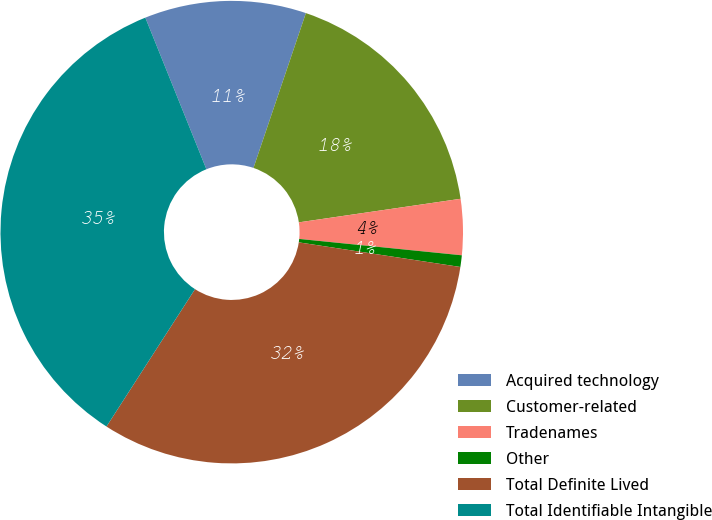<chart> <loc_0><loc_0><loc_500><loc_500><pie_chart><fcel>Acquired technology<fcel>Customer-related<fcel>Tradenames<fcel>Other<fcel>Total Definite Lived<fcel>Total Identifiable Intangible<nl><fcel>11.29%<fcel>17.5%<fcel>3.9%<fcel>0.81%<fcel>31.7%<fcel>34.79%<nl></chart> 